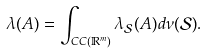Convert formula to latex. <formula><loc_0><loc_0><loc_500><loc_500>\lambda ( A ) = \int _ { C C ( \mathbb { R } ^ { m } ) } \lambda _ { \mathcal { S } } ( A ) d \nu ( \mathcal { S } ) .</formula> 